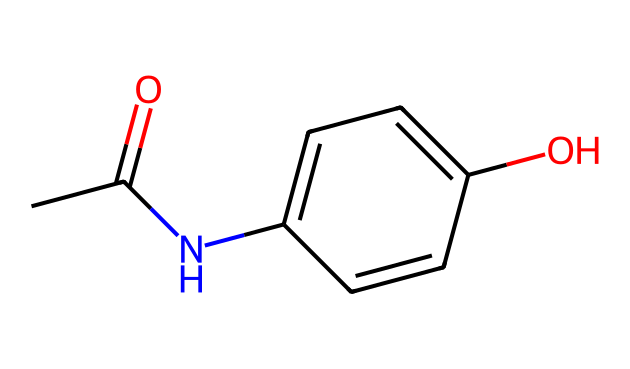What is the molecular formula of this compound? By analyzing the structure, we can identify the atoms present: there are 10 carbon atoms, 11 hydrogen atoms, 1 nitrogen atom, and 3 oxygen atoms. Therefore, the molecular formula is C10H11N1O3.
Answer: C10H11NO3 How many rings are present in the structure? The structure shows one cyclic component, which is the benzene ring formed by the six carbon atoms, indicating one ring is present.
Answer: 1 What functional groups are present in this compound? The structure reveals an amide group (from the nitrogen) and a hydroxyl group (from the -OH), which are both common functional groups.
Answer: amide and hydroxyl What type of drug is this compound categorized as? This compound is a painkiller used to reduce pain and fever, notably classified as an analgesic and antipyretic.
Answer: analgesic What is the significance of the acetyl group in this compound? The presence of the acetyl group (indicated by the CC(=O) part) is crucial as it enhances the compound’s analgesic properties and is characteristic of paracetamol (acetaminophen).
Answer: enhances analgesic properties What is the number of hydrogen bonding sites in this molecule? Analyzing the structure, the hydroxyl (-OH) and amide groups can participate in hydrogen bonding, giving this compound 2 potential hydrogen bonding sites.
Answer: 2 